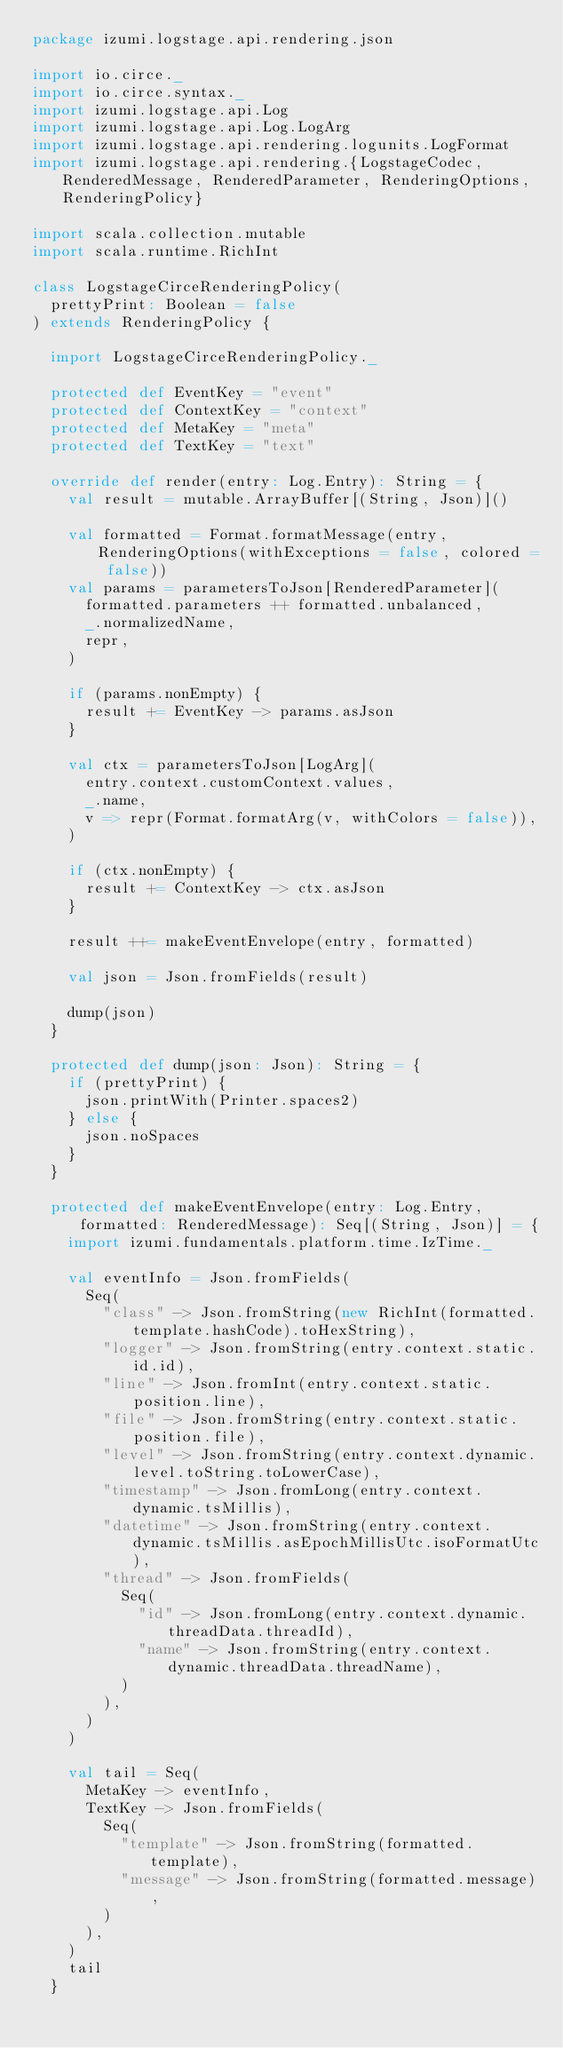<code> <loc_0><loc_0><loc_500><loc_500><_Scala_>package izumi.logstage.api.rendering.json

import io.circe._
import io.circe.syntax._
import izumi.logstage.api.Log
import izumi.logstage.api.Log.LogArg
import izumi.logstage.api.rendering.logunits.LogFormat
import izumi.logstage.api.rendering.{LogstageCodec, RenderedMessage, RenderedParameter, RenderingOptions, RenderingPolicy}

import scala.collection.mutable
import scala.runtime.RichInt

class LogstageCirceRenderingPolicy(
  prettyPrint: Boolean = false
) extends RenderingPolicy {

  import LogstageCirceRenderingPolicy._

  protected def EventKey = "event"
  protected def ContextKey = "context"
  protected def MetaKey = "meta"
  protected def TextKey = "text"

  override def render(entry: Log.Entry): String = {
    val result = mutable.ArrayBuffer[(String, Json)]()

    val formatted = Format.formatMessage(entry, RenderingOptions(withExceptions = false, colored = false))
    val params = parametersToJson[RenderedParameter](
      formatted.parameters ++ formatted.unbalanced,
      _.normalizedName,
      repr,
    )

    if (params.nonEmpty) {
      result += EventKey -> params.asJson
    }

    val ctx = parametersToJson[LogArg](
      entry.context.customContext.values,
      _.name,
      v => repr(Format.formatArg(v, withColors = false)),
    )

    if (ctx.nonEmpty) {
      result += ContextKey -> ctx.asJson
    }

    result ++= makeEventEnvelope(entry, formatted)

    val json = Json.fromFields(result)

    dump(json)
  }

  protected def dump(json: Json): String = {
    if (prettyPrint) {
      json.printWith(Printer.spaces2)
    } else {
      json.noSpaces
    }
  }

  protected def makeEventEnvelope(entry: Log.Entry, formatted: RenderedMessage): Seq[(String, Json)] = {
    import izumi.fundamentals.platform.time.IzTime._

    val eventInfo = Json.fromFields(
      Seq(
        "class" -> Json.fromString(new RichInt(formatted.template.hashCode).toHexString),
        "logger" -> Json.fromString(entry.context.static.id.id),
        "line" -> Json.fromInt(entry.context.static.position.line),
        "file" -> Json.fromString(entry.context.static.position.file),
        "level" -> Json.fromString(entry.context.dynamic.level.toString.toLowerCase),
        "timestamp" -> Json.fromLong(entry.context.dynamic.tsMillis),
        "datetime" -> Json.fromString(entry.context.dynamic.tsMillis.asEpochMillisUtc.isoFormatUtc),
        "thread" -> Json.fromFields(
          Seq(
            "id" -> Json.fromLong(entry.context.dynamic.threadData.threadId),
            "name" -> Json.fromString(entry.context.dynamic.threadData.threadName),
          )
        ),
      )
    )

    val tail = Seq(
      MetaKey -> eventInfo,
      TextKey -> Json.fromFields(
        Seq(
          "template" -> Json.fromString(formatted.template),
          "message" -> Json.fromString(formatted.message),
        )
      ),
    )
    tail
  }
</code> 